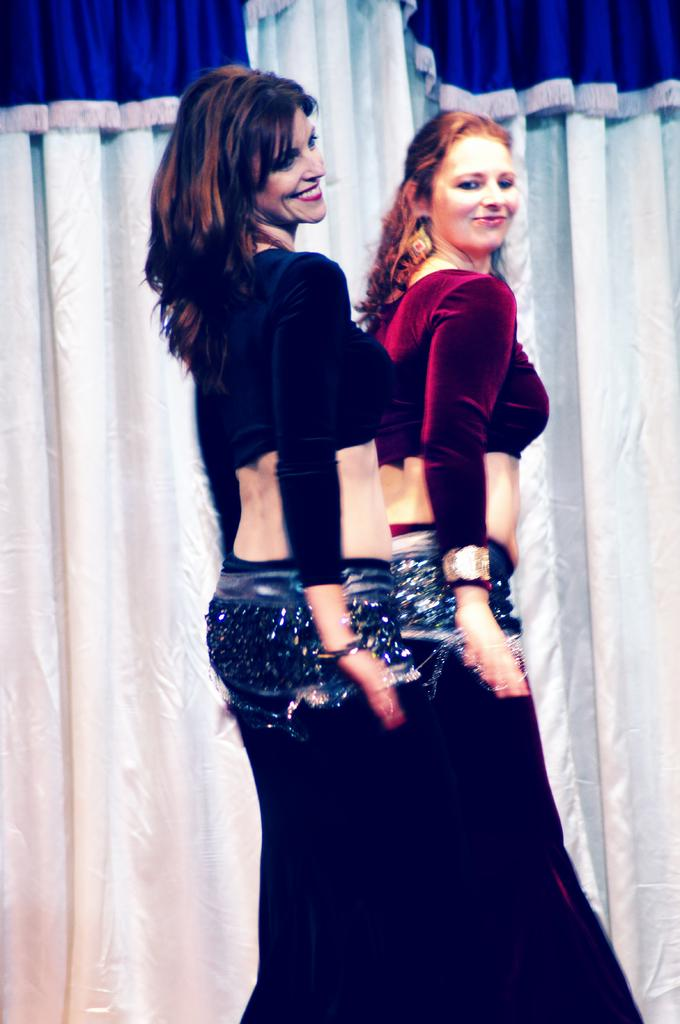How many people are in the foreground of the image? There are two women in the foreground of the image. What are the women doing in the image? The women are doing belly dance. What can be seen in the background of the image? There is a white and blue curtain in the background of the image. What type of cannon is being used by the women in the image? There is no cannon present in the image; the women are doing belly dance. What color is the chalk used by the women in the image? There is no chalk present in the image; the women are doing belly dance. 